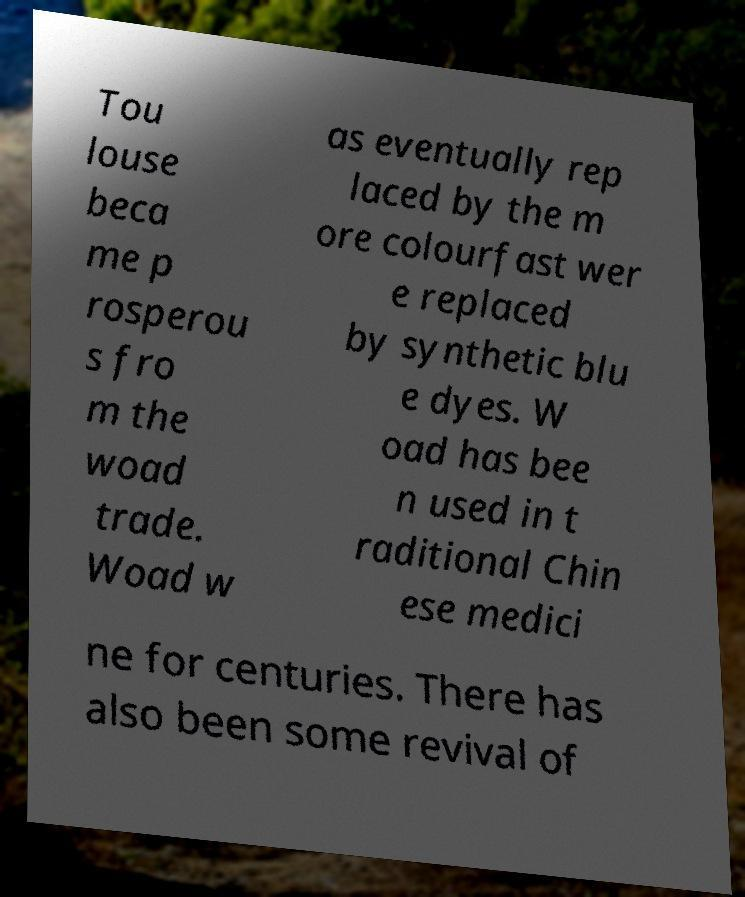Please read and relay the text visible in this image. What does it say? Tou louse beca me p rosperou s fro m the woad trade. Woad w as eventually rep laced by the m ore colourfast wer e replaced by synthetic blu e dyes. W oad has bee n used in t raditional Chin ese medici ne for centuries. There has also been some revival of 